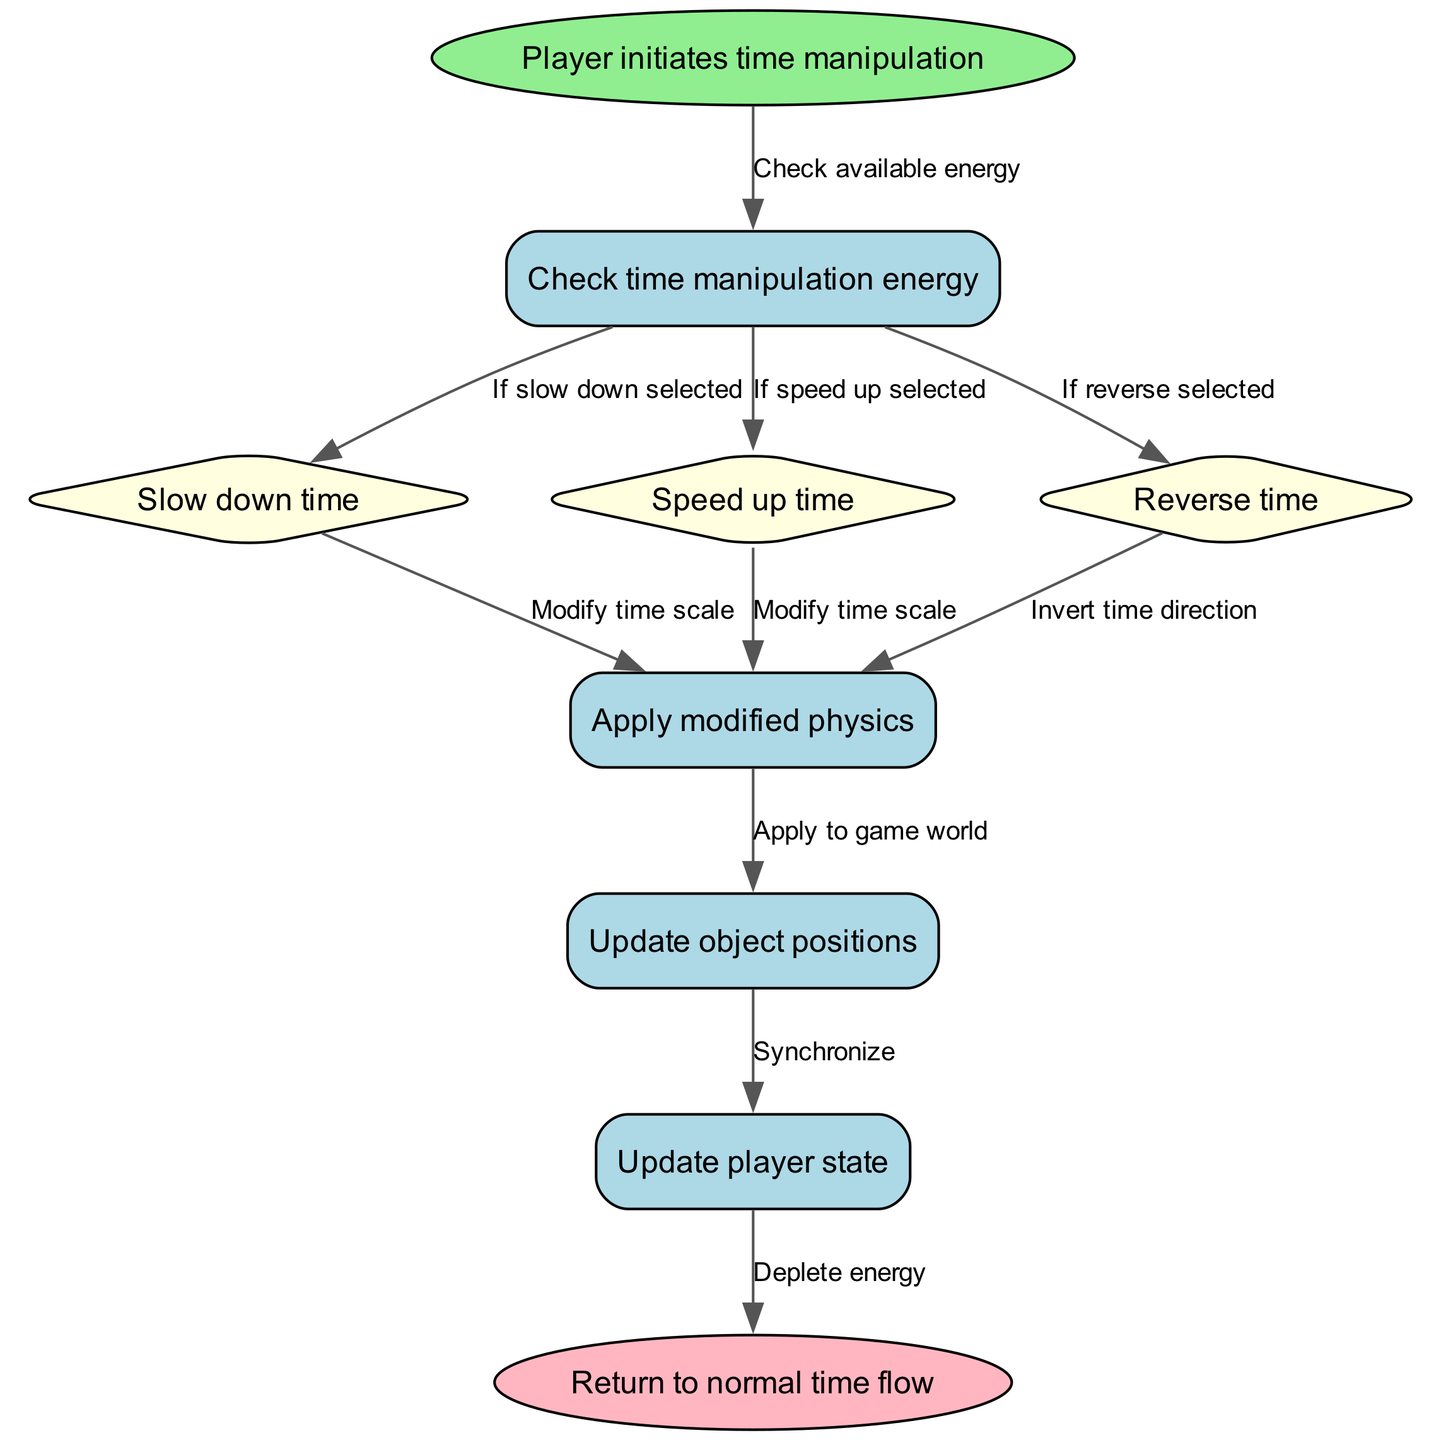What is the first node the player interacts with? The diagram starts with a node labeled "Player initiates time manipulation," which indicates that this is the initial action taken by the player.
Answer: Player initiates time manipulation How many different time manipulation options are present? The flowchart includes three distinct manipulation options: "Slow down time," "Speed up time," and "Reverse time," totaling three options.
Answer: 3 What is the shape of the node representing the end of time manipulation? The end node is defined as an ellipse, indicating that it visually differs from other nodes, which are mostly rectangles or diamonds.
Answer: ellipse What happens after the energy check if "slow down time" is selected? If "slow down time" is chosen after checking energy, the next step is to modify the time scale as reflected in the flow.
Answer: Modify time scale Which node is connected to "Update object positions"? The node "Update object positions" is linked directly from the "Apply modified physics" node, showing the flow from physics to the object positions.
Answer: Apply modified physics What action depletes the energy? The flowchart indicates that depleting energy occurs at the node "Update player state," which is the final step after synchronizing with object positions.
Answer: Update player state Which node would follow "Check available energy" when "Reverse time" is selected? If "Reverse time" is chosen after "Check available energy," it leads to the node titled "Invert time direction," indicating the action performed.
Answer: Invert time direction What color is used for the node representing the "Slow down time" option? The node designated for "Slow down time" is filled with light yellow, which identifies it among other nodes in a consistent style.
Answer: light yellow What label is given to the edge connecting "Player initiates time manipulation" to "Check available energy"? The edge between these two nodes is labeled as "Check available energy," clearly indicating the action taken before engaging in time manipulation.
Answer: Check available energy 